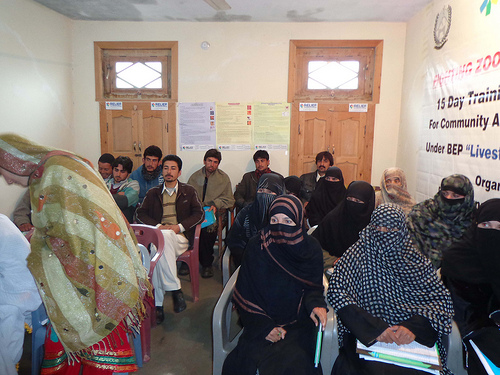<image>
Can you confirm if the woman is to the left of the woman? Yes. From this viewpoint, the woman is positioned to the left side relative to the woman. Is there a woman behind the chair? No. The woman is not behind the chair. From this viewpoint, the woman appears to be positioned elsewhere in the scene. 